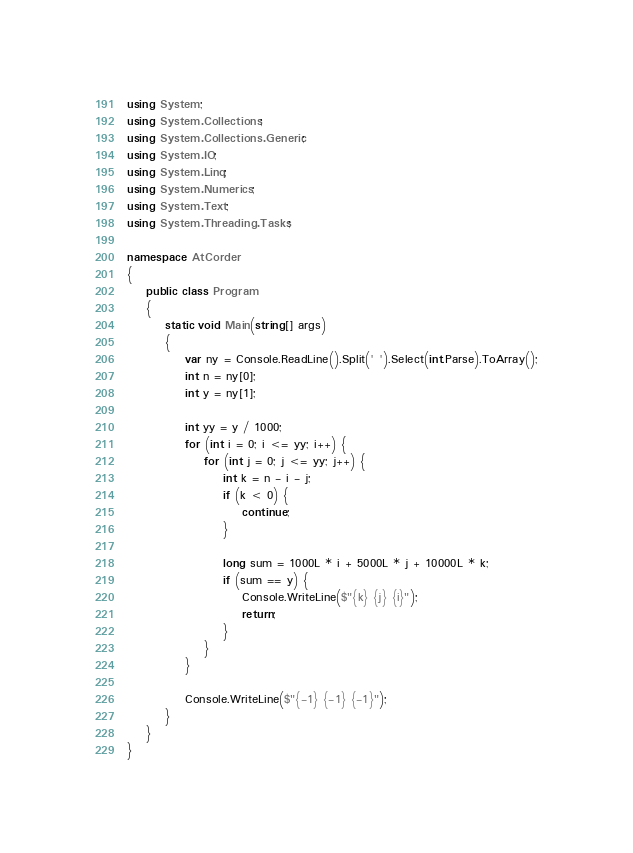<code> <loc_0><loc_0><loc_500><loc_500><_C#_>using System;
using System.Collections;
using System.Collections.Generic;
using System.IO;
using System.Linq;
using System.Numerics;
using System.Text;
using System.Threading.Tasks;
 
namespace AtCorder
{
	public class Program
	{
		static void Main(string[] args)
		{
			var ny = Console.ReadLine().Split(' ').Select(int.Parse).ToArray();
			int n = ny[0];
			int y = ny[1];

			int yy = y / 1000;
			for (int i = 0; i <= yy; i++) {
				for (int j = 0; j <= yy; j++) {
					int k = n - i - j;
					if (k < 0) {
						continue;
					}

					long sum = 1000L * i + 5000L * j + 10000L * k;
					if (sum == y) {
						Console.WriteLine($"{k} {j} {i}");
						return;
					}
				}
			}

			Console.WriteLine($"{-1} {-1} {-1}");
		}		
	}
}</code> 